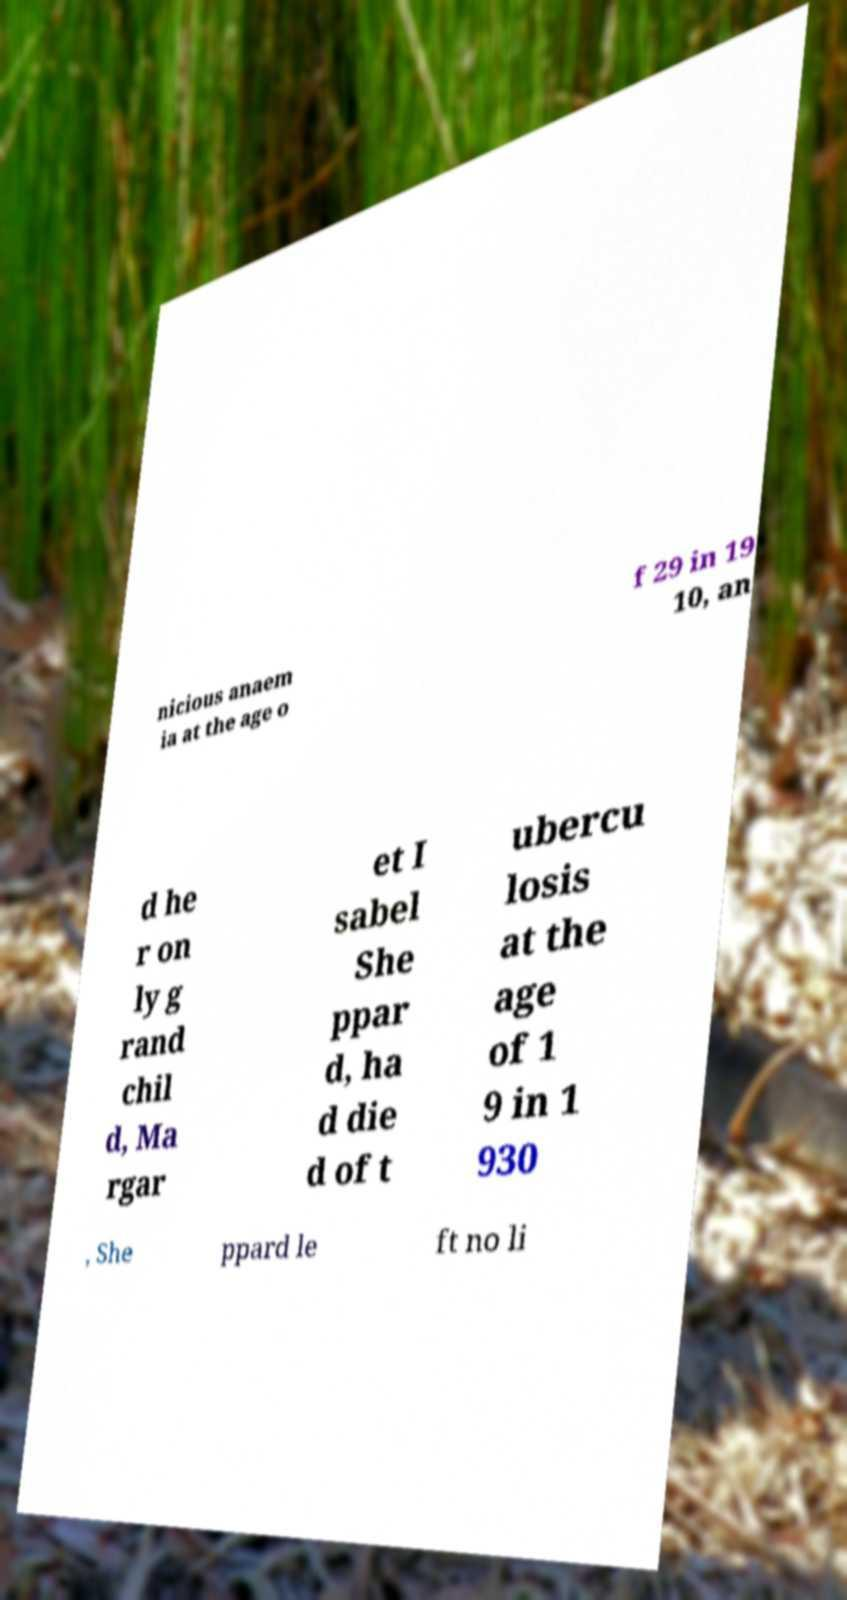Please read and relay the text visible in this image. What does it say? nicious anaem ia at the age o f 29 in 19 10, an d he r on ly g rand chil d, Ma rgar et I sabel She ppar d, ha d die d of t ubercu losis at the age of 1 9 in 1 930 , She ppard le ft no li 